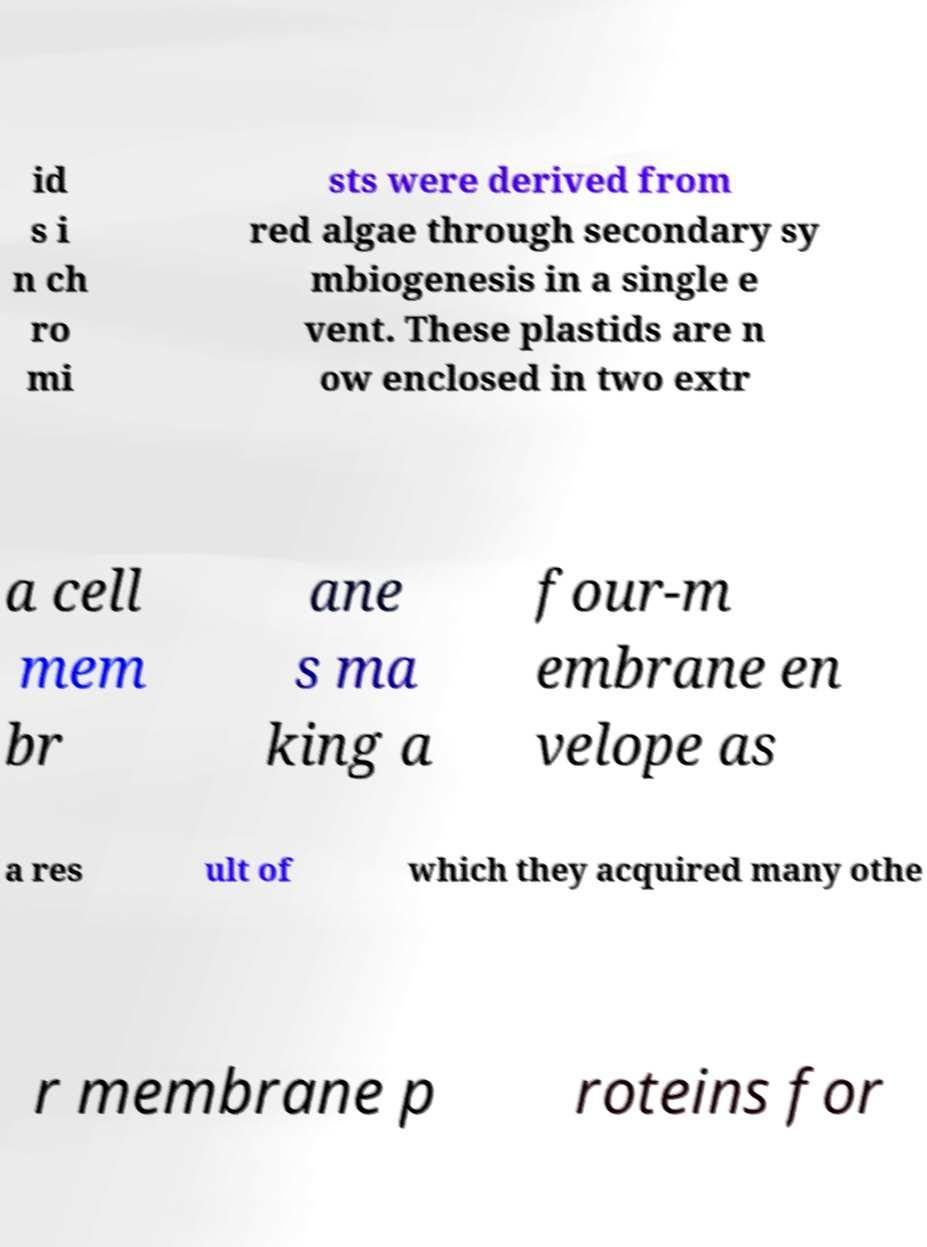What messages or text are displayed in this image? I need them in a readable, typed format. id s i n ch ro mi sts were derived from red algae through secondary sy mbiogenesis in a single e vent. These plastids are n ow enclosed in two extr a cell mem br ane s ma king a four-m embrane en velope as a res ult of which they acquired many othe r membrane p roteins for 